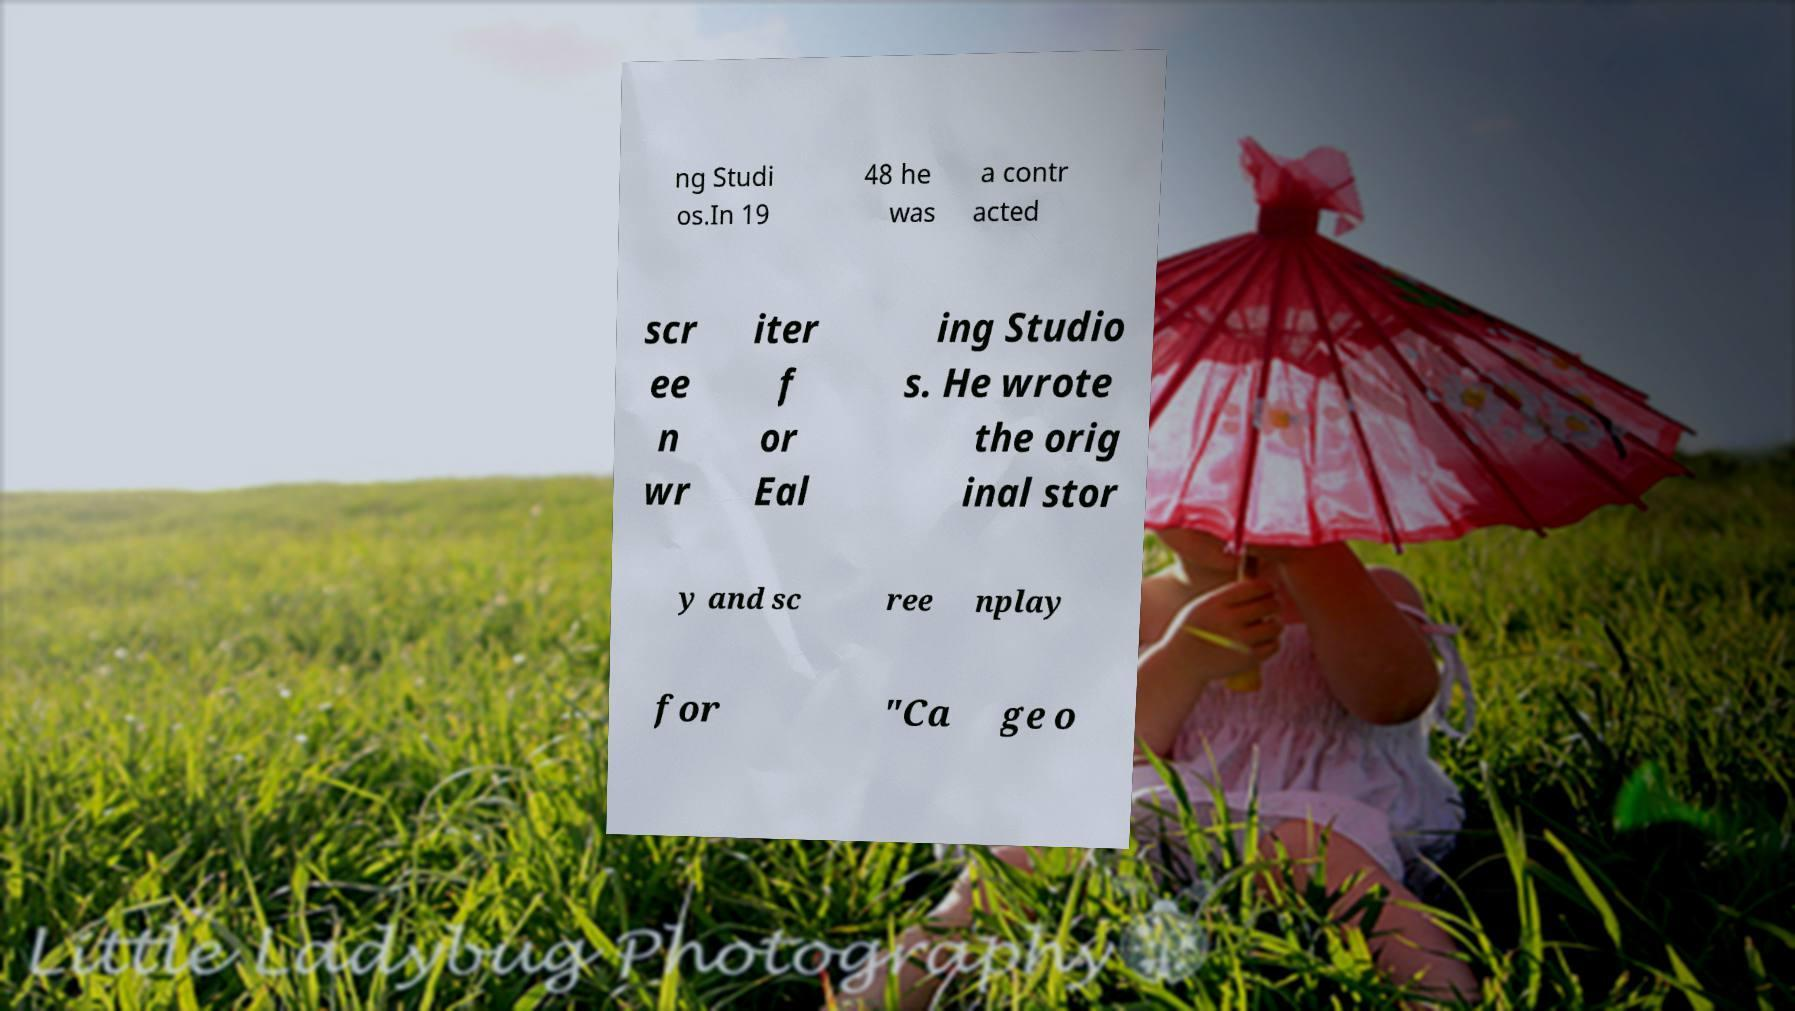What messages or text are displayed in this image? I need them in a readable, typed format. ng Studi os.In 19 48 he was a contr acted scr ee n wr iter f or Eal ing Studio s. He wrote the orig inal stor y and sc ree nplay for "Ca ge o 